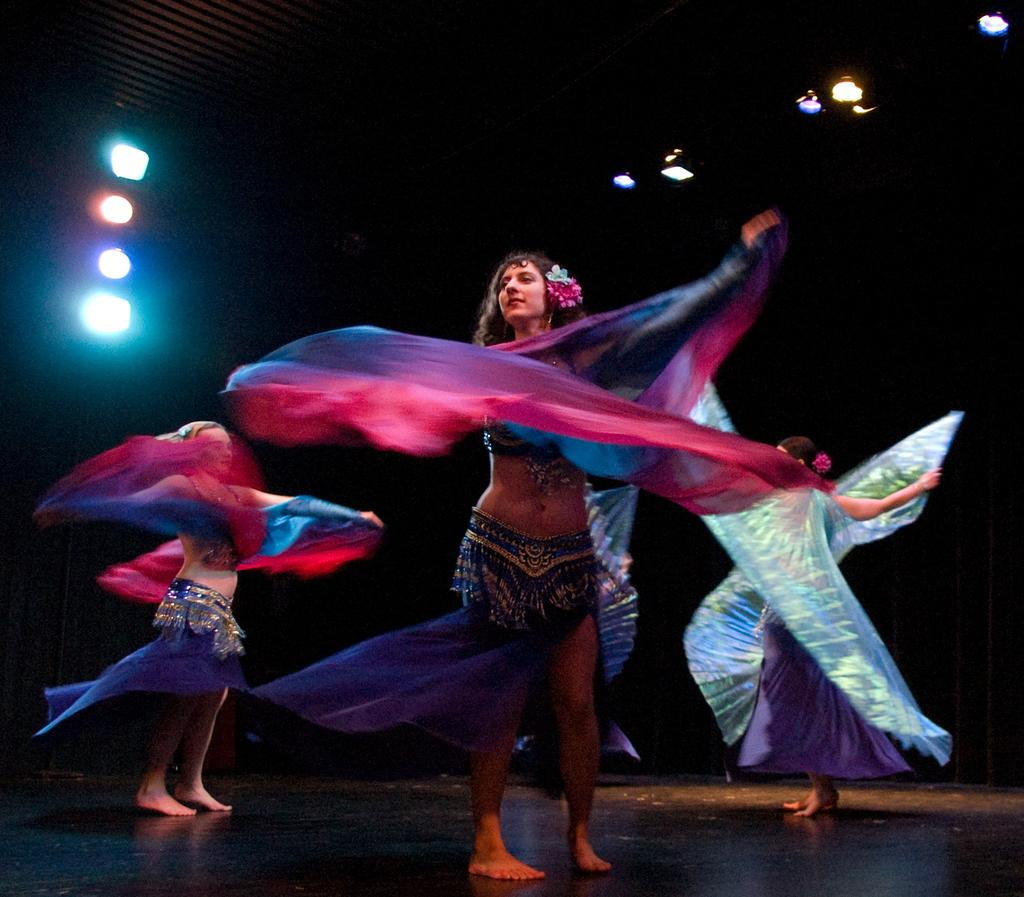How many people are in the image? There are three persons in the image. What are the persons wearing? The persons are wearing clothes. Where are the lights located in the image? There are lights in the top left and top right of the image. What type of disgust can be seen on the faces of the persons in the image? There is no indication of disgust on the faces of the persons in the image. What type of chain is connecting the persons in the image? There is no chain connecting the persons in the image. Can you see a kitten in the image? There is no kitten present in the image. 